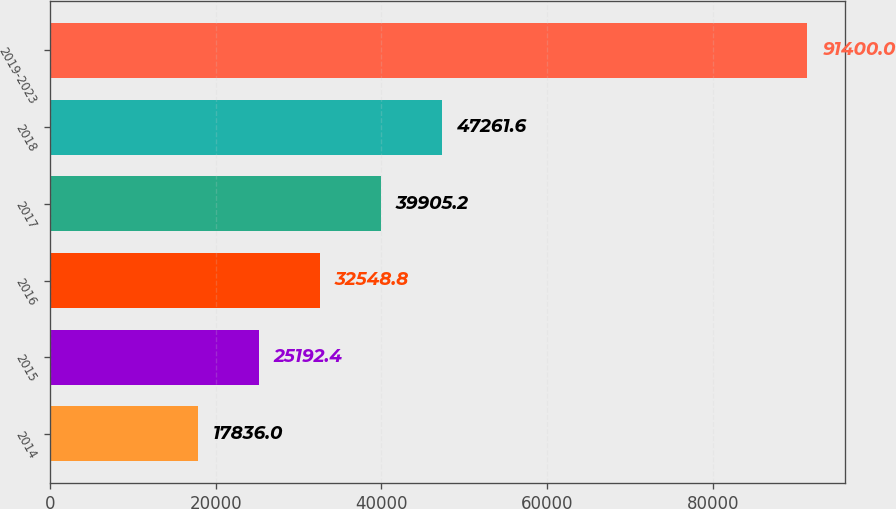Convert chart. <chart><loc_0><loc_0><loc_500><loc_500><bar_chart><fcel>2014<fcel>2015<fcel>2016<fcel>2017<fcel>2018<fcel>2019-2023<nl><fcel>17836<fcel>25192.4<fcel>32548.8<fcel>39905.2<fcel>47261.6<fcel>91400<nl></chart> 